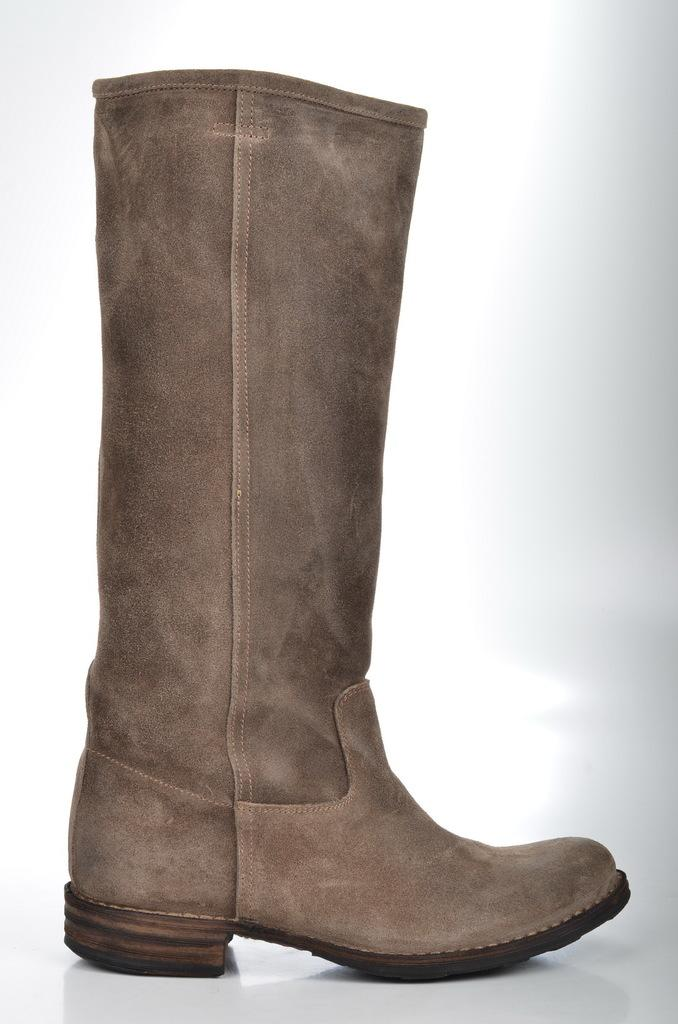What color is the boot in the image? The boot in the image is brown-colored. What can be seen in the background of the image? The background of the image is white. What type of property is being sold in the image? There is no property being sold in the image; it only features a brown-colored boot and a white background. What level of toothpaste is recommended for use with the boot in the image? There is no toothpaste or recommendation for toothpaste in the image; it only features a brown-colored boot and a white background. 